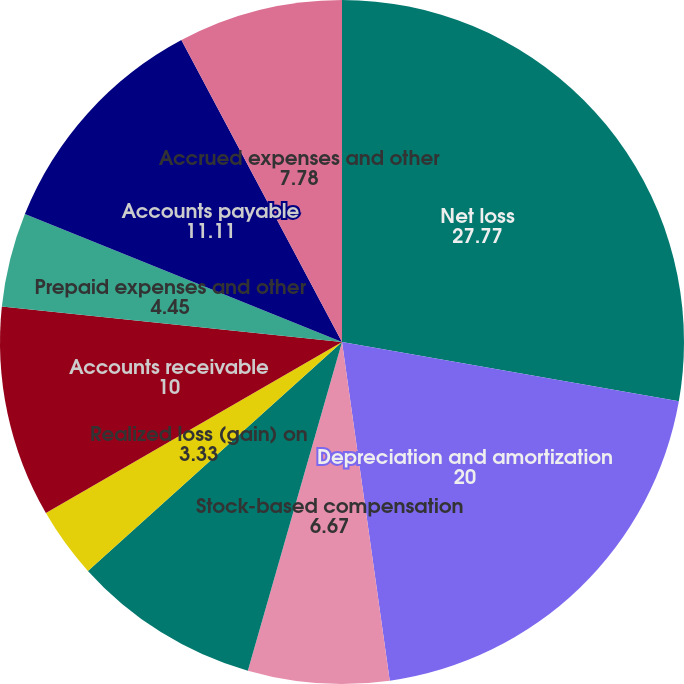<chart> <loc_0><loc_0><loc_500><loc_500><pie_chart><fcel>Net loss<fcel>Depreciation and amortization<fcel>Stock-based compensation<fcel>Other non-cash based<fcel>Loss on disposal of property<fcel>Realized loss (gain) on<fcel>Accounts receivable<fcel>Prepaid expenses and other<fcel>Accounts payable<fcel>Accrued expenses and other<nl><fcel>27.77%<fcel>20.0%<fcel>6.67%<fcel>8.89%<fcel>0.0%<fcel>3.33%<fcel>10.0%<fcel>4.45%<fcel>11.11%<fcel>7.78%<nl></chart> 